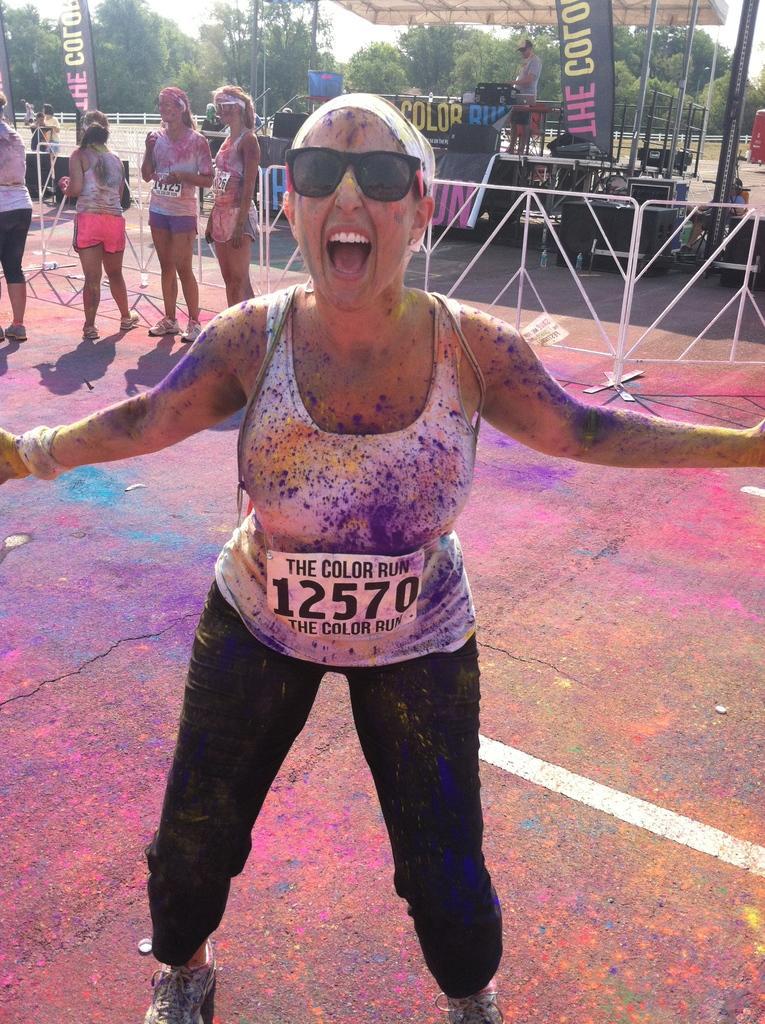Please provide a concise description of this image. In this picture I can see a woman standing in front and I see that, there is color all over her body. In the background I can see railings and I can see few people standing. On the top of this picture, I can see few banners on which there is something written and I can see number of trees. 